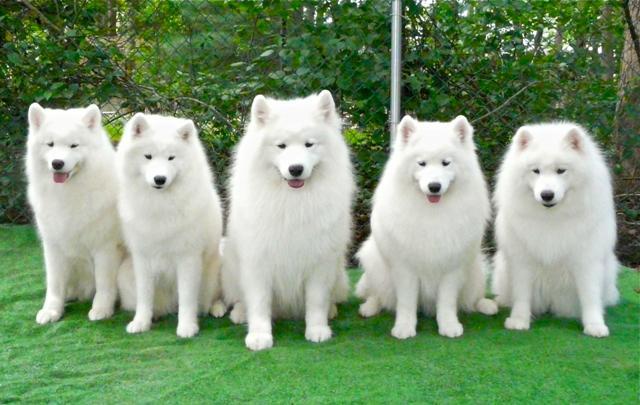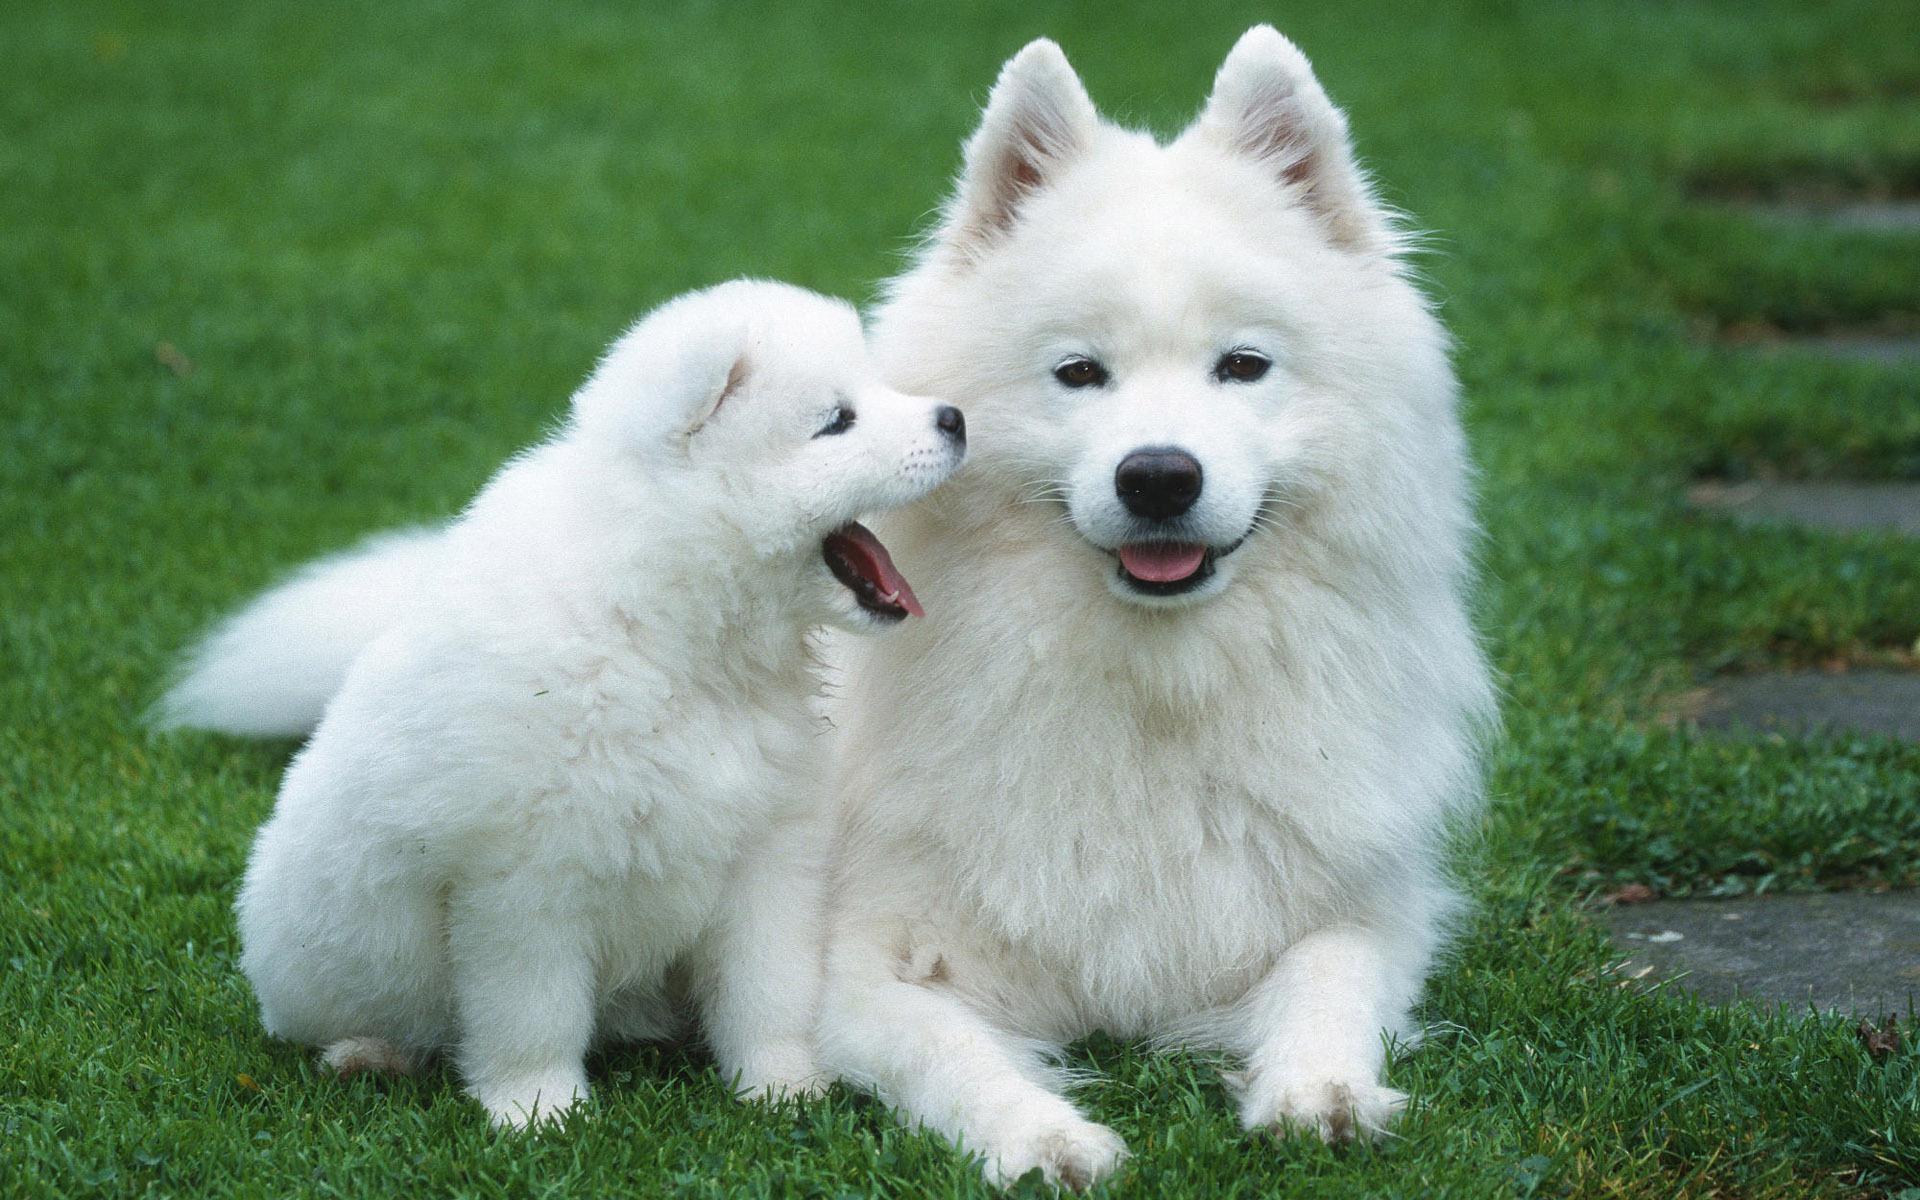The first image is the image on the left, the second image is the image on the right. For the images shown, is this caption "In one of the images, there are two white dogs and at least one dog of another color." true? Answer yes or no. No. 